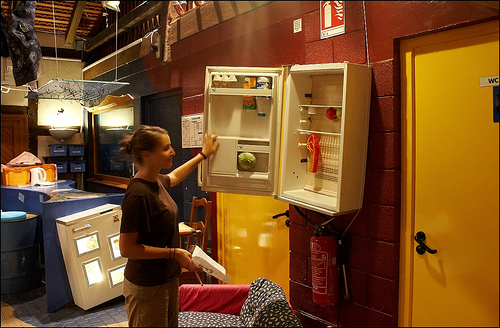Extract all visible text content from this image. WC 